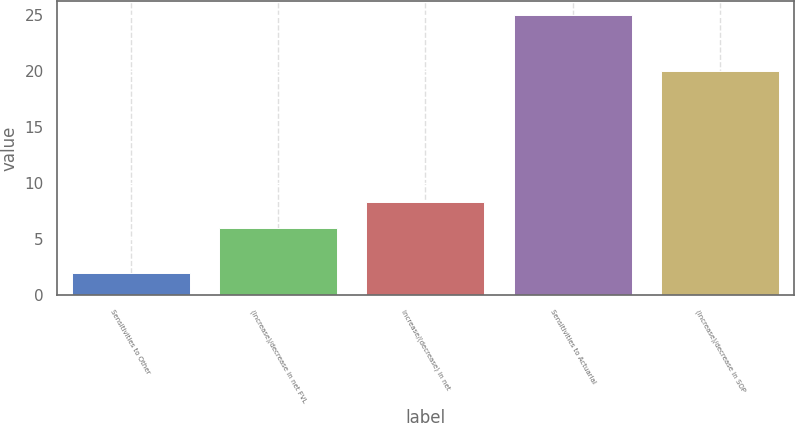Convert chart. <chart><loc_0><loc_0><loc_500><loc_500><bar_chart><fcel>Sensitivities to Other<fcel>(Increase)/decrease in net FVL<fcel>Increase/(decrease) in net<fcel>Sensitivities to Actuarial<fcel>(Increase)/decrease in SOP<nl><fcel>2<fcel>6<fcel>8.3<fcel>25<fcel>20<nl></chart> 